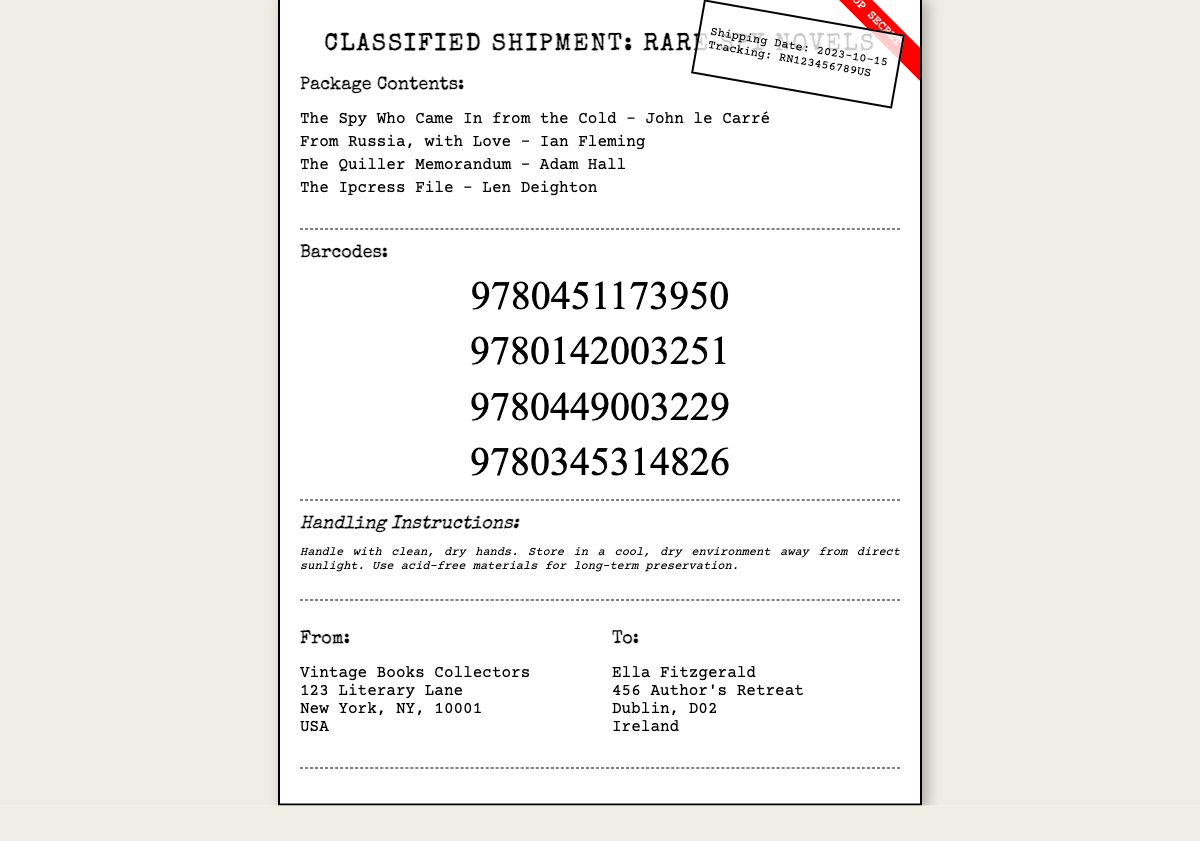What is the title of the first book? The title of the first book is listed under "Package Contents" in the document, which is "The Spy Who Came In from the Cold."
Answer: The Spy Who Came In from the Cold Who is the author of "From Russia, with Love"? The author of this novel is indicated in the "Package Contents" section, which names "Ian Fleming" as the author.
Answer: Ian Fleming What is the shipping date? The shipping date is written on the stamp in the upper right corner of the label, noted as "2023-10-15."
Answer: 2023-10-15 What is the barcode for "The Ipcress File"? The barcode is part of the "Barcodes" section, specifically tied to "The Ipcress File," which contains "9780345314826."
Answer: 9780345314826 Who is the recipient of this package? The recipient's name is provided under the "To:" section of the shipping details, where it states "Ella Fitzgerald."
Answer: Ella Fitzgerald What are the handling instructions regarding the storage condition? The handling instructions outline the storage requirements, emphasizing a "cool, dry environment away from direct sunlight."
Answer: cool, dry environment away from direct sunlight How many books are listed in the package? The total number of novels is noted in the "Package Contents" section, identifying four titles.
Answer: 4 What type of label is the document classified as? The header denotes the nature of the shipment as "Classified Shipment: Rare Spy Novels."
Answer: Classified Shipment: Rare Spy Novels 